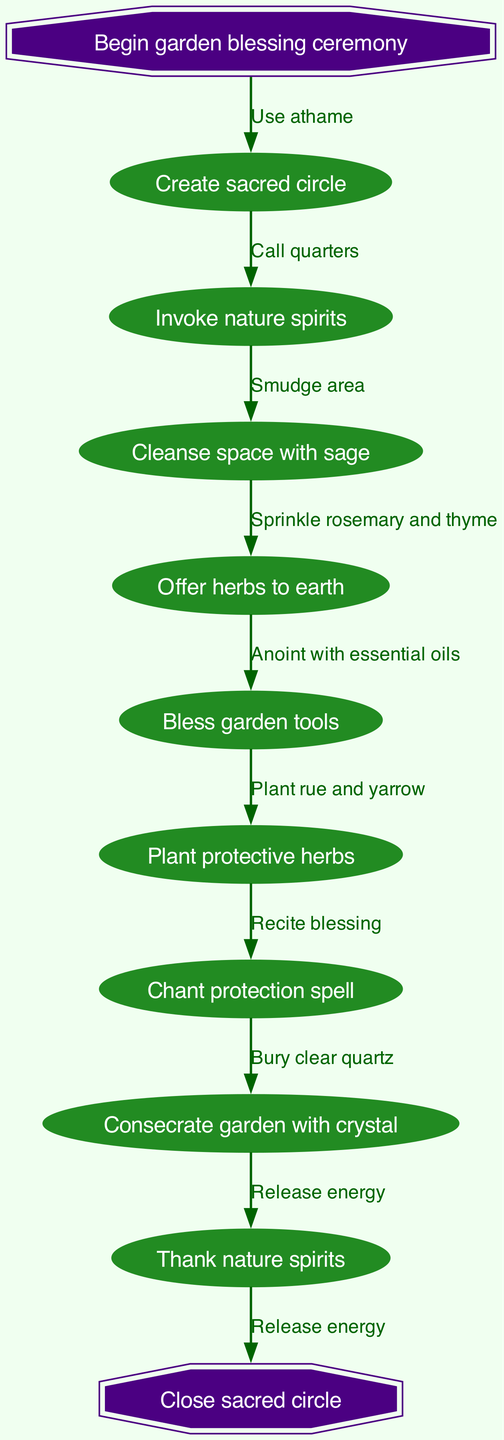What is the first step in the garden blessing ceremony? The first step is indicated as "Create sacred circle," which is the first node connected to the start node.
Answer: Create sacred circle How many nodes are present in the diagram? By counting the individual nodes listed in the data, there are nine nodes: one starting node, seven process nodes, and one ending node.
Answer: 9 What is connected to the end of the ceremony? The diagram shows that "Close sacred circle" is the final node connected to the last process node, indicated by the last edge in the flow.
Answer: Close sacred circle What is the purpose of the node "Bless garden tools"? The node "Bless garden tools" represents a specific action within the ceremony and is a critical component for preparing tools for the ritual, which enhances their effectiveness.
Answer: Preparing tools Which node follows "Cleansed space with sage"? After "Cleanse space with sage," the next node in the sequence is "Offer herbs to earth," indicating the flow of the ceremony in the order depicted.
Answer: Offer herbs to earth How many edges are there connecting the nodes? By counting the connections from the start node through to the end node, there are eight edges present, which correspond to connections between the nodes.
Answer: 8 What is the last action in the ceremony before closing the circle? The last action before closing the ceremony is "Thank nature spirits," which is the second to last node in the flow, just prior to the ending node.
Answer: Thank nature spirits Which action is performed after "Plant protective herbs"? Following the action "Plant protective herbs," the next process node is "Chant protection spell," which continues the sequence of the ritual.
Answer: Chant protection spell What is the first edge connected to the start node? The first edge connected to the start node is labeled "Use athame," which indicates the initial action performed in the ceremony linked to the starting point.
Answer: Use athame 